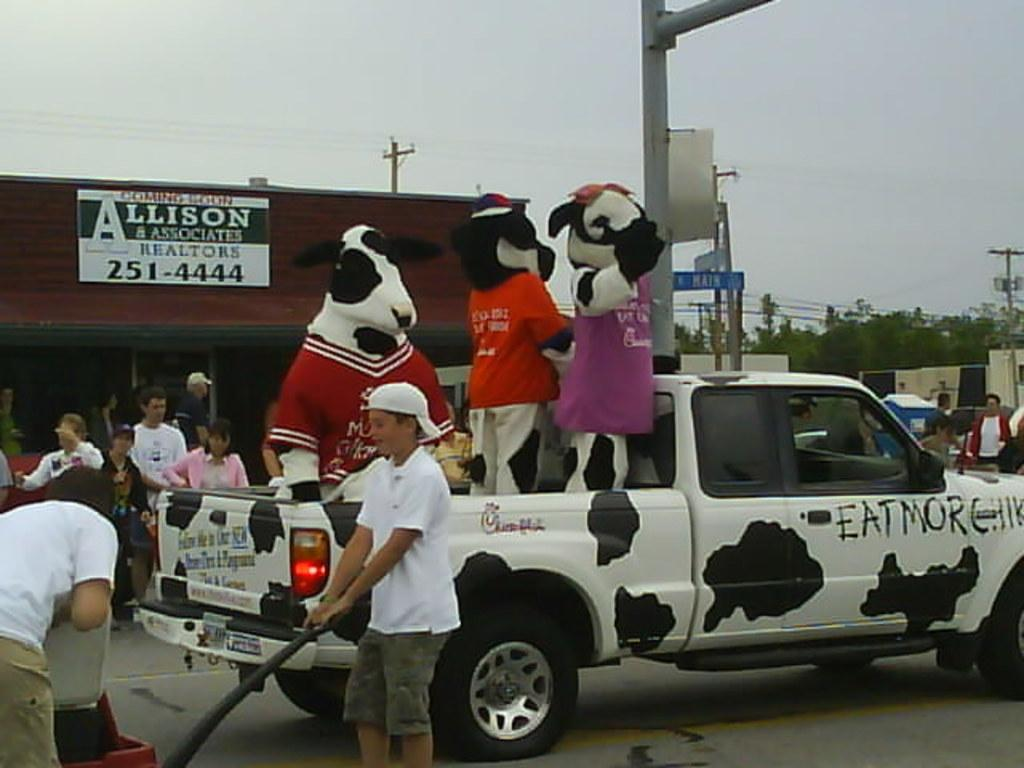How many people are in the group visible in the image? The number of people in the group is not specified, but there is a group of people in the image. What is on the road in the image? There is a vehicle on the road in the image. What can be seen in the background of the image? In the background of the image, there is a shed, trees, electric poles, and some unspecified objects. What is visible in the sky in the image? The sky is visible in the background of the image, but no specific details about the sky are provided. What type of linen is draped over the cave in the image? There is no cave or linen present in the image. How does the spark from the vehicle affect the group of people in the image? There is no spark or indication of a spark in the image, so it cannot affect the group of people. 